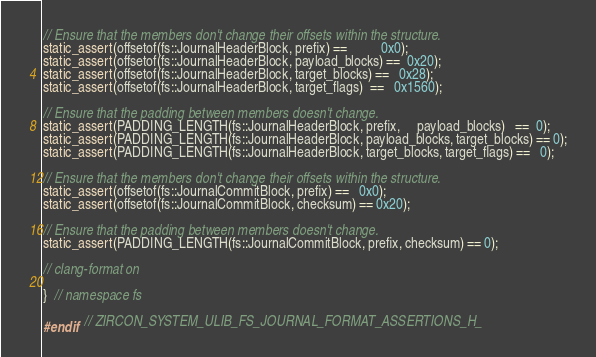Convert code to text. <code><loc_0><loc_0><loc_500><loc_500><_C_>
// Ensure that the members don't change their offsets within the structure.
static_assert(offsetof(fs::JournalHeaderBlock, prefix) ==          0x0);
static_assert(offsetof(fs::JournalHeaderBlock, payload_blocks) ==  0x20);
static_assert(offsetof(fs::JournalHeaderBlock, target_blocks) ==   0x28);
static_assert(offsetof(fs::JournalHeaderBlock, target_flags)  ==   0x1560);

// Ensure that the padding between members doesn't change.
static_assert(PADDING_LENGTH(fs::JournalHeaderBlock, prefix,     payload_blocks)   ==  0);
static_assert(PADDING_LENGTH(fs::JournalHeaderBlock, payload_blocks, target_blocks) == 0);
static_assert(PADDING_LENGTH(fs::JournalHeaderBlock, target_blocks, target_flags) ==   0);

// Ensure that the members don't change their offsets within the structure.
static_assert(offsetof(fs::JournalCommitBlock, prefix) ==   0x0);
static_assert(offsetof(fs::JournalCommitBlock, checksum) == 0x20);

// Ensure that the padding between members doesn't change.
static_assert(PADDING_LENGTH(fs::JournalCommitBlock, prefix, checksum) == 0);

// clang-format on

}  // namespace fs

#endif  // ZIRCON_SYSTEM_ULIB_FS_JOURNAL_FORMAT_ASSERTIONS_H_
</code> 